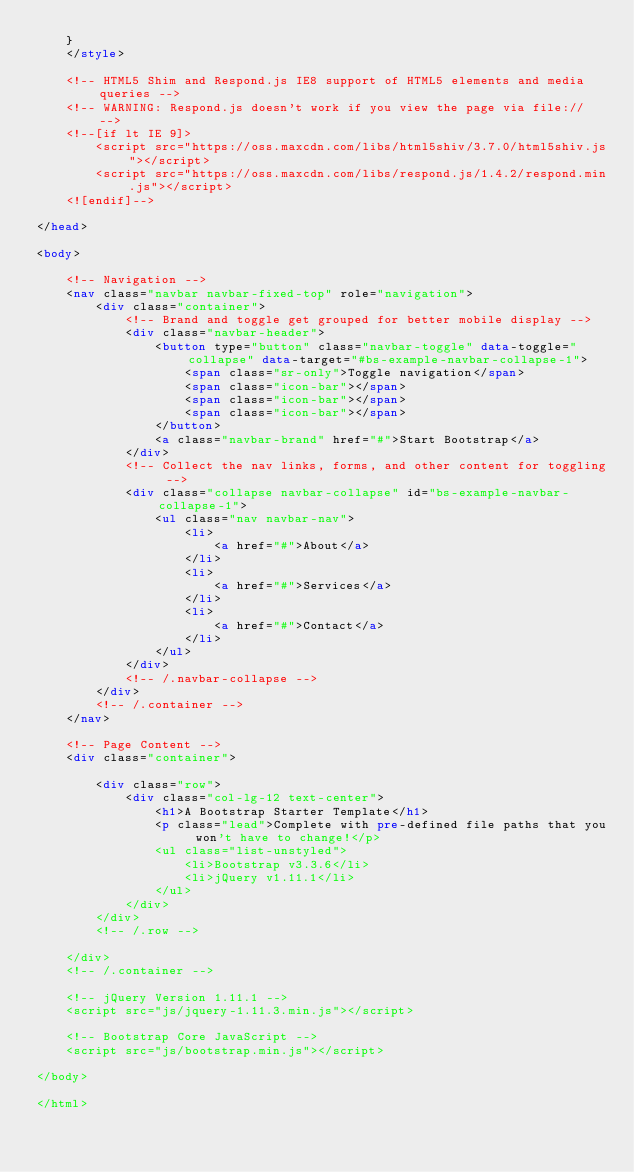<code> <loc_0><loc_0><loc_500><loc_500><_HTML_>    }
    </style>

    <!-- HTML5 Shim and Respond.js IE8 support of HTML5 elements and media queries -->
    <!-- WARNING: Respond.js doesn't work if you view the page via file:// -->
    <!--[if lt IE 9]>
        <script src="https://oss.maxcdn.com/libs/html5shiv/3.7.0/html5shiv.js"></script>
        <script src="https://oss.maxcdn.com/libs/respond.js/1.4.2/respond.min.js"></script>
    <![endif]-->

</head>

<body>

    <!-- Navigation -->
    <nav class="navbar navbar-fixed-top" role="navigation">
        <div class="container">
            <!-- Brand and toggle get grouped for better mobile display -->
            <div class="navbar-header">
                <button type="button" class="navbar-toggle" data-toggle="collapse" data-target="#bs-example-navbar-collapse-1">
                    <span class="sr-only">Toggle navigation</span>
                    <span class="icon-bar"></span>
                    <span class="icon-bar"></span>
                    <span class="icon-bar"></span>
                </button>
                <a class="navbar-brand" href="#">Start Bootstrap</a>
            </div>
            <!-- Collect the nav links, forms, and other content for toggling -->
            <div class="collapse navbar-collapse" id="bs-example-navbar-collapse-1">
                <ul class="nav navbar-nav">
                    <li>
                        <a href="#">About</a>
                    </li>
                    <li>
                        <a href="#">Services</a>
                    </li>
                    <li>
                        <a href="#">Contact</a>
                    </li>
                </ul>
            </div>
            <!-- /.navbar-collapse -->
        </div>
        <!-- /.container -->
    </nav>

    <!-- Page Content -->
    <div class="container">

        <div class="row">
            <div class="col-lg-12 text-center">
                <h1>A Bootstrap Starter Template</h1>
                <p class="lead">Complete with pre-defined file paths that you won't have to change!</p>
                <ul class="list-unstyled">
                    <li>Bootstrap v3.3.6</li>
                    <li>jQuery v1.11.1</li>
                </ul>
            </div>
        </div>
        <!-- /.row -->

    </div>
    <!-- /.container -->

    <!-- jQuery Version 1.11.1 -->
    <script src="js/jquery-1.11.3.min.js"></script>

    <!-- Bootstrap Core JavaScript -->
    <script src="js/bootstrap.min.js"></script>

</body>

</html>
</code> 